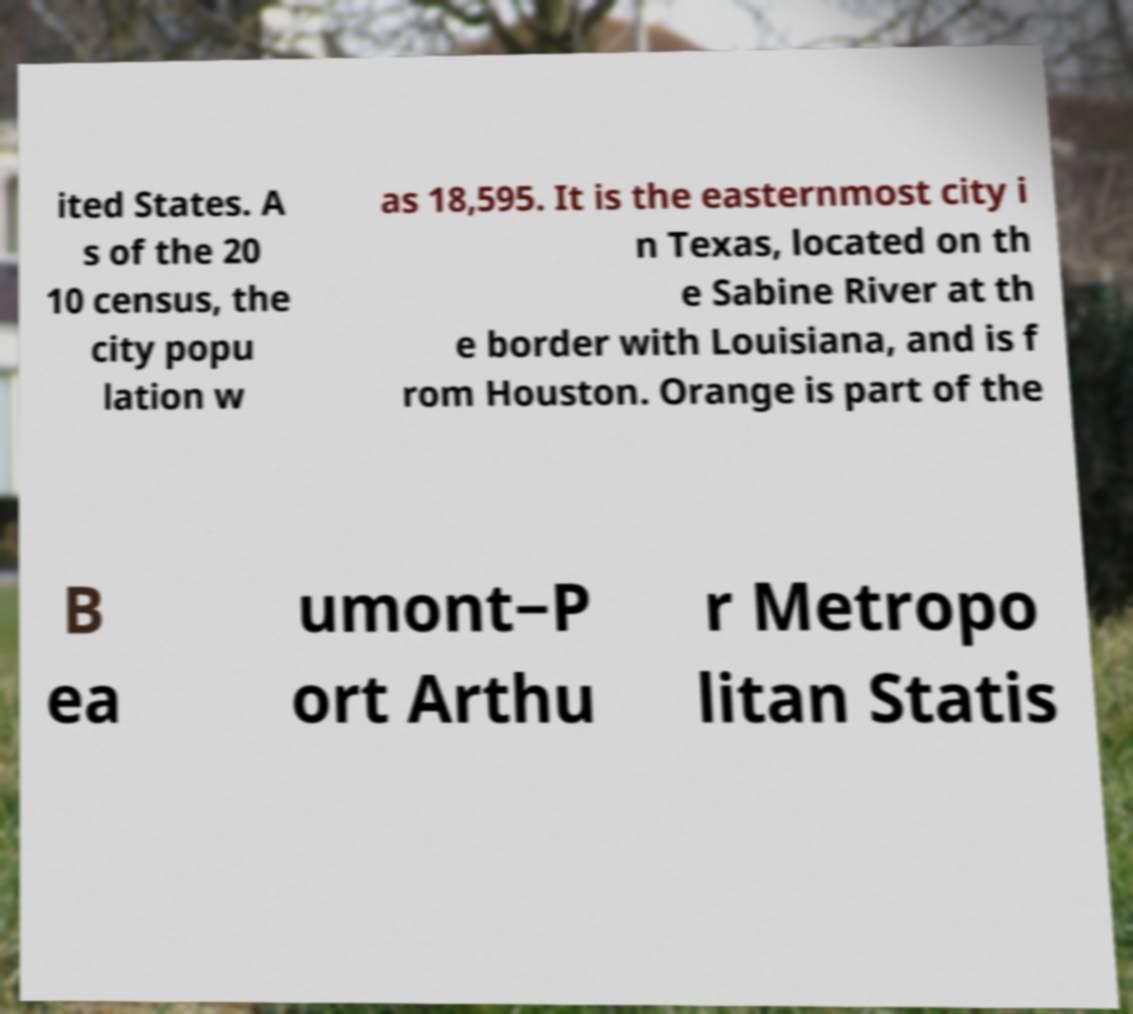Could you assist in decoding the text presented in this image and type it out clearly? ited States. A s of the 20 10 census, the city popu lation w as 18,595. It is the easternmost city i n Texas, located on th e Sabine River at th e border with Louisiana, and is f rom Houston. Orange is part of the B ea umont−P ort Arthu r Metropo litan Statis 